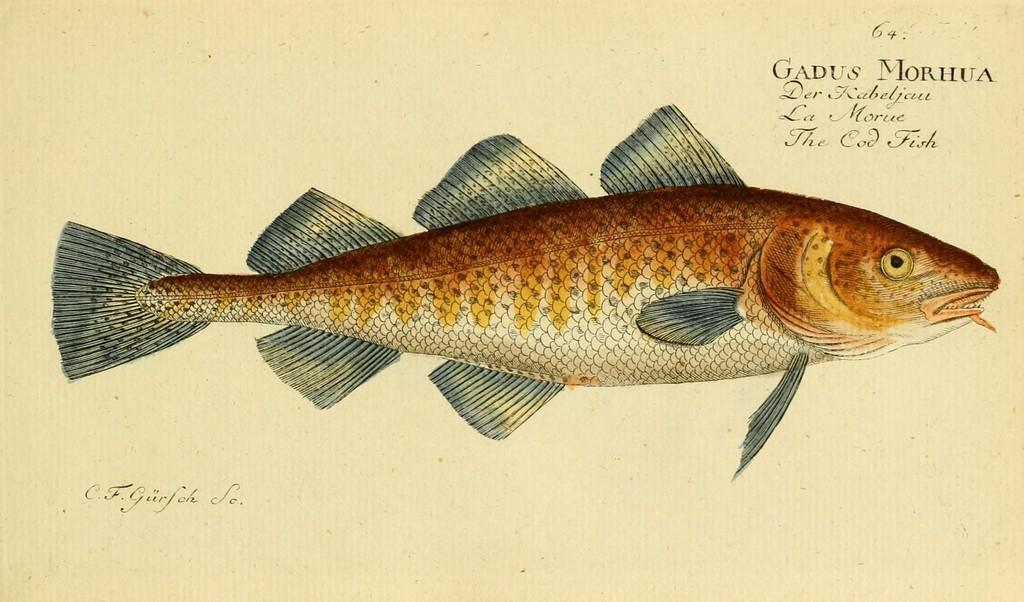What type of image is being described? The image is animated. What is the main subject of the image? There is a fish in the center of the image. Where can text be found in the image? There is text at the top and bottom of the image. How many giants are visible in the image? There are no giants present in the image; it features an animated fish and text. What type of ink is used for the text in the image? There is no information about the type of ink used for the text in the image. 